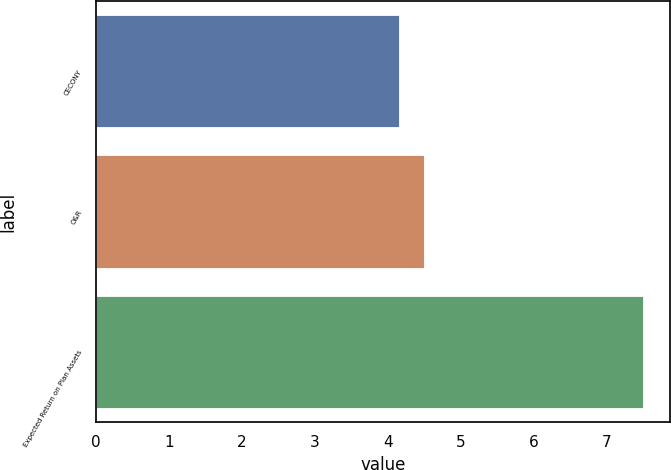Convert chart to OTSL. <chart><loc_0><loc_0><loc_500><loc_500><bar_chart><fcel>CECONY<fcel>O&R<fcel>Expected Return on Plan Assets<nl><fcel>4.15<fcel>4.49<fcel>7.5<nl></chart> 